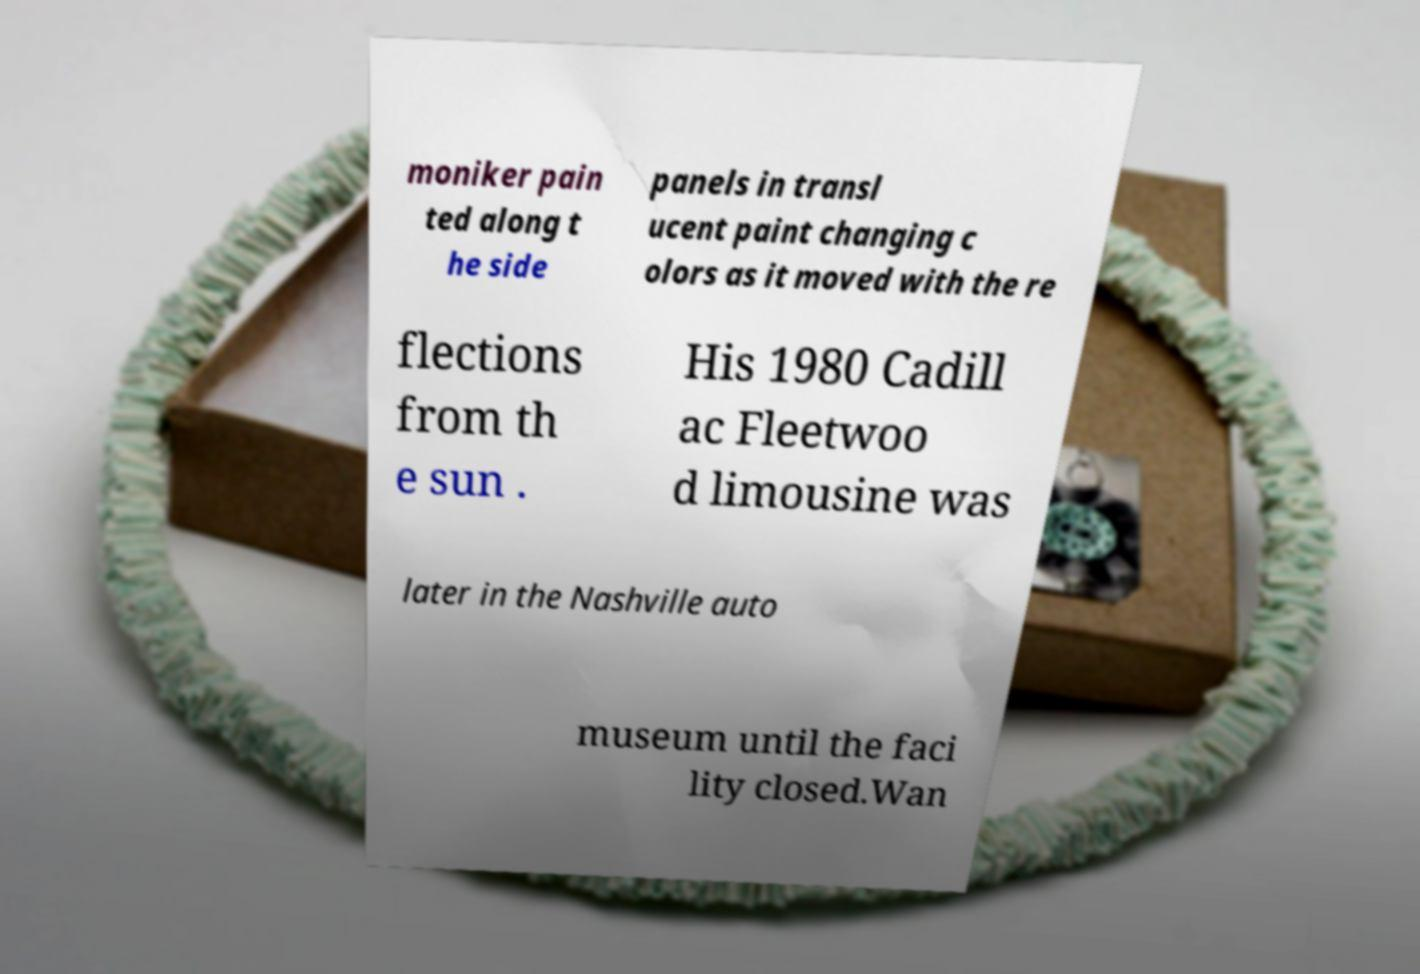Could you extract and type out the text from this image? moniker pain ted along t he side panels in transl ucent paint changing c olors as it moved with the re flections from th e sun . His 1980 Cadill ac Fleetwoo d limousine was later in the Nashville auto museum until the faci lity closed.Wan 